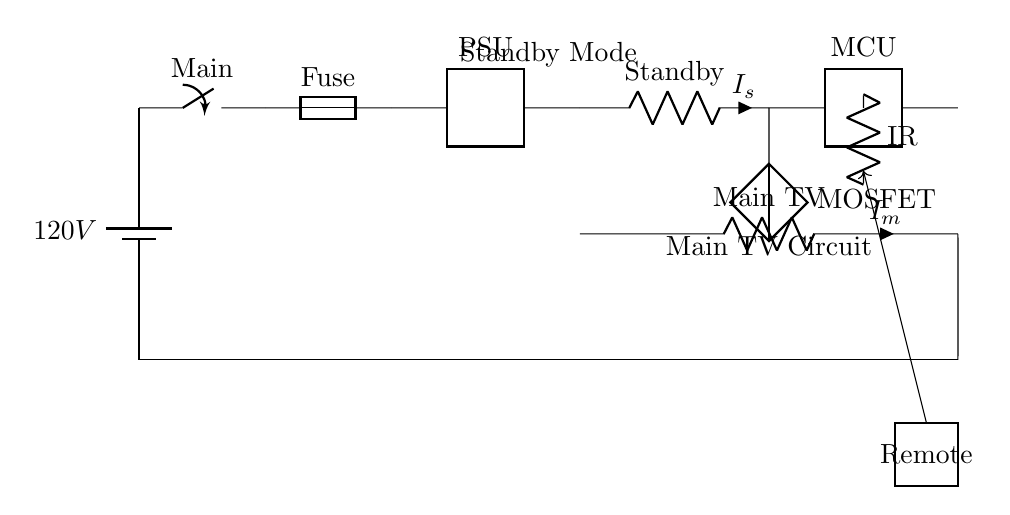What is the voltage of the power source? The circuit shows a battery labeled with a voltage of 120V, which is the voltage supplied to the circuit.
Answer: 120V What component controls the power flow in this circuit? The main switch is identified in the diagram, which acts as the component that controls the flow of electricity within the circuit when opened or closed.
Answer: Main switch What type of current do the resistors represent? The circuit diagram indicates the presence of two resistors, one for standby mode and one for the main TV circuit, representing resistive loads that consume power, specifically in standby and operational modes.
Answer: Resistors What is the purpose of the microcontroller? The microcontroller is essential for managing the functions of the TV, including switching between modes and receiving commands from the remote, thus controlling the overall operation of the TV.
Answer: Control operations Which component is responsible for receiving signals from the remote control? The infrared (IR) receiver is labeled in the circuit, specifically designed to pick up signals from the remote control device, enabling the user to interact with the TV wirelessly.
Answer: IR receiver What indicates the standby circuit's current? The diagram indicates that the standby circuit has a current labeled as Is, which specifies the flow of current when the TV is in the standby mode and is consuming power to remain responsive to the remote.
Answer: Is How does the MOSFET function in this circuit? The MOSFET acts as a switch or amplifier in the circuit, allowing control of the main TV circuit's power based on signals from the microcontroller, thus efficiently managing power consumption.
Answer: Switch 